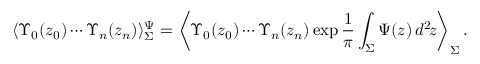<formula> <loc_0><loc_0><loc_500><loc_500>\langle \Upsilon _ { 0 } ( z _ { 0 } ) \cdots \Upsilon _ { n } ( z _ { n } ) \rangle _ { \Sigma } ^ { \Psi } = \left \langle \Upsilon _ { 0 } ( z _ { 0 } ) \cdots \Upsilon _ { n } ( z _ { n } ) \exp \frac { 1 } { \pi } \int _ { \Sigma } \Psi ( z ) \, d ^ { 2 } \, z \right \rangle _ { \Sigma } .</formula> 